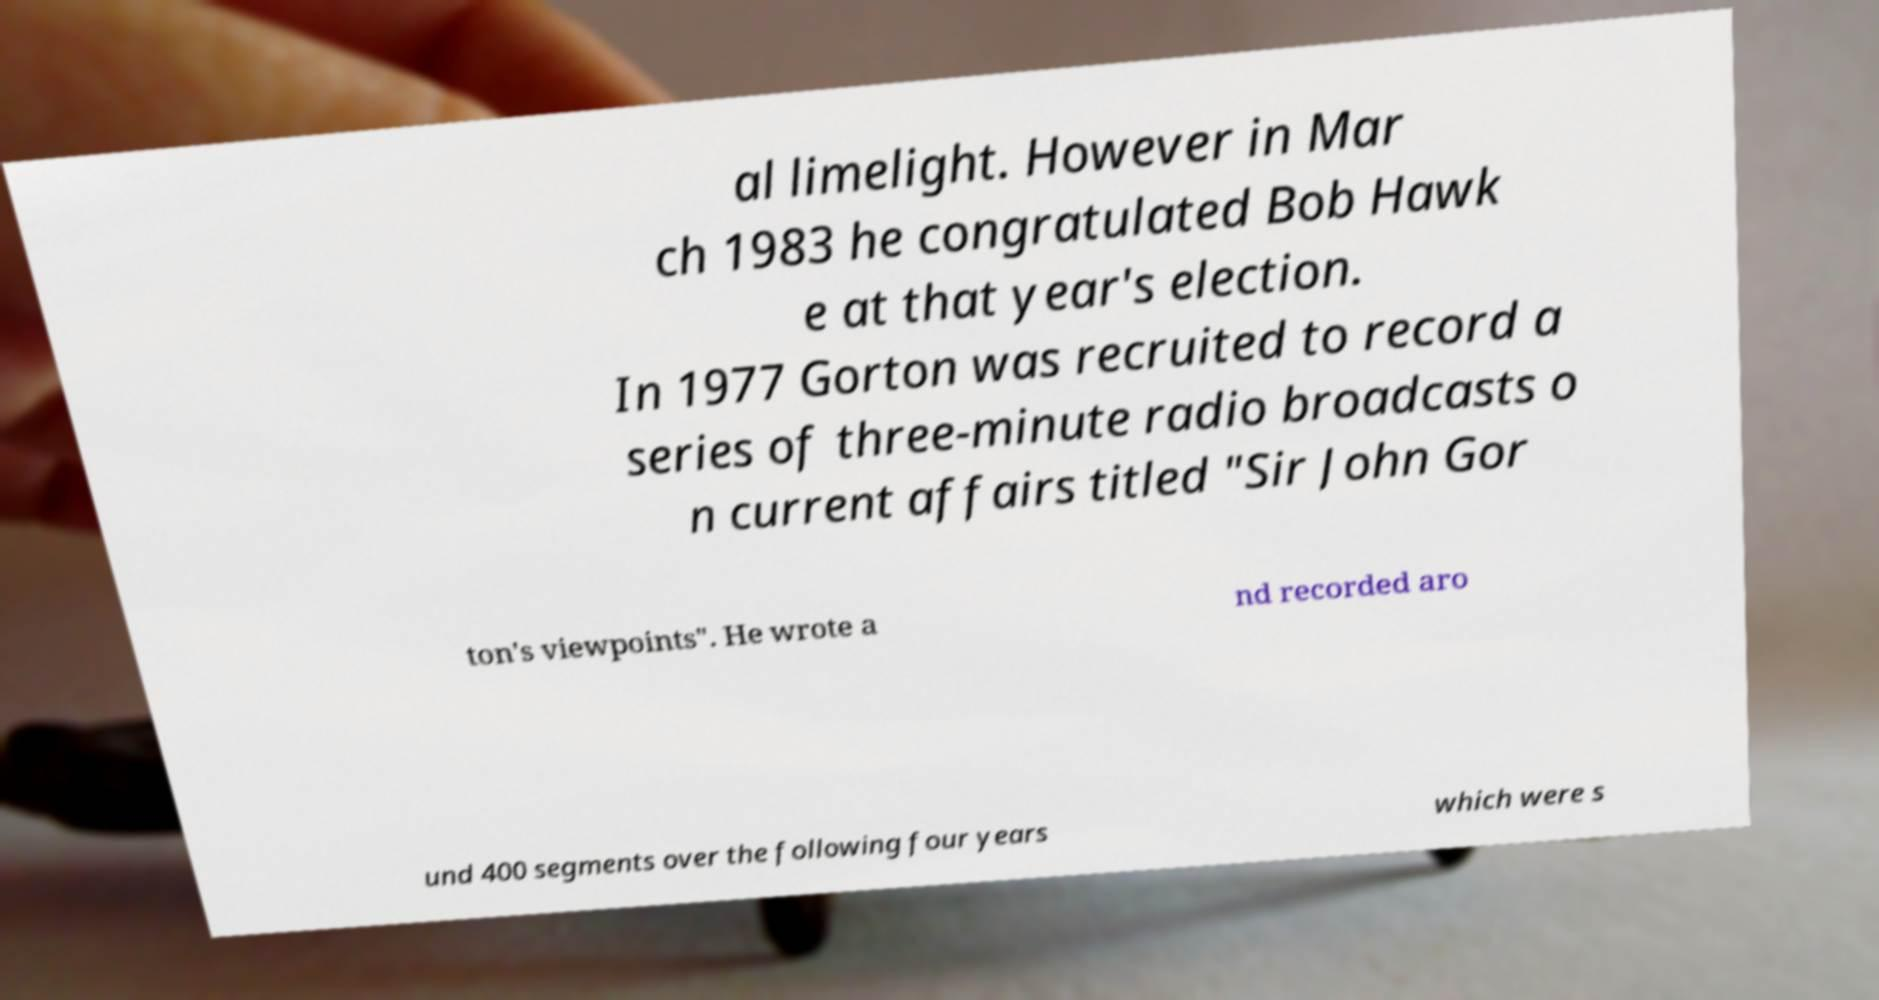Can you read and provide the text displayed in the image?This photo seems to have some interesting text. Can you extract and type it out for me? al limelight. However in Mar ch 1983 he congratulated Bob Hawk e at that year's election. In 1977 Gorton was recruited to record a series of three-minute radio broadcasts o n current affairs titled "Sir John Gor ton's viewpoints". He wrote a nd recorded aro und 400 segments over the following four years which were s 